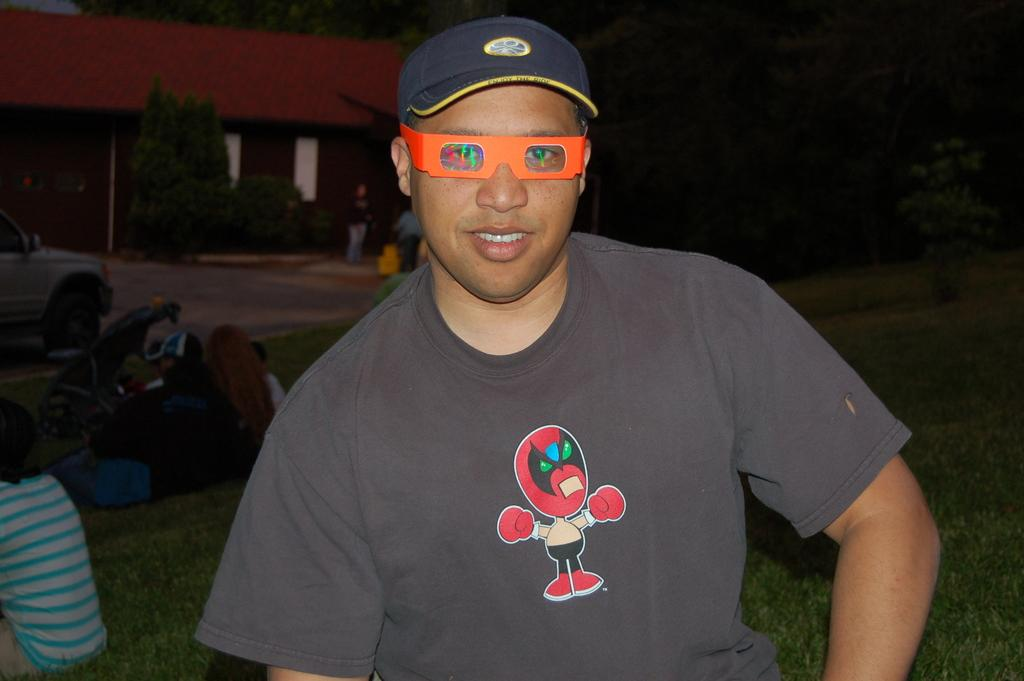What is the person in the image wearing? The person in the image is wearing clothes and spectacles. What are the people in the image doing? The people in the image are sitting on the grass. What can be seen in the top left of the image? There is a tree and a shelter house in the top left of the image. How many chickens are there in the image? There are no chickens present in the image. What type of cub is playing with the person in the image? There is no cub present in the image. 